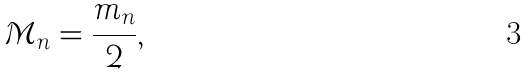Convert formula to latex. <formula><loc_0><loc_0><loc_500><loc_500>\mathcal { M } _ { n } = \frac { m _ { n } } { 2 } ,</formula> 